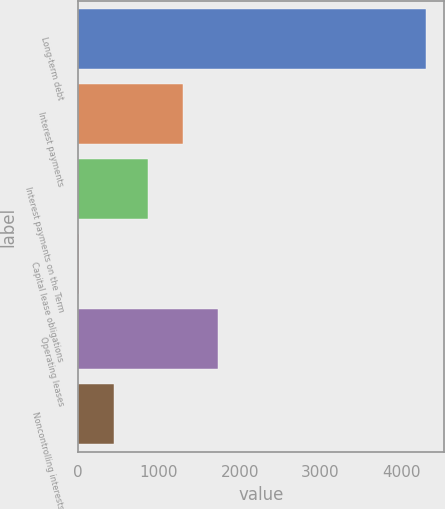Convert chart. <chart><loc_0><loc_0><loc_500><loc_500><bar_chart><fcel>Long-term debt<fcel>Interest payments<fcel>Interest payments on the Term<fcel>Capital lease obligations<fcel>Operating leases<fcel>Noncontrolling interests<nl><fcel>4309<fcel>1298.3<fcel>868.2<fcel>8<fcel>1728.4<fcel>438.1<nl></chart> 